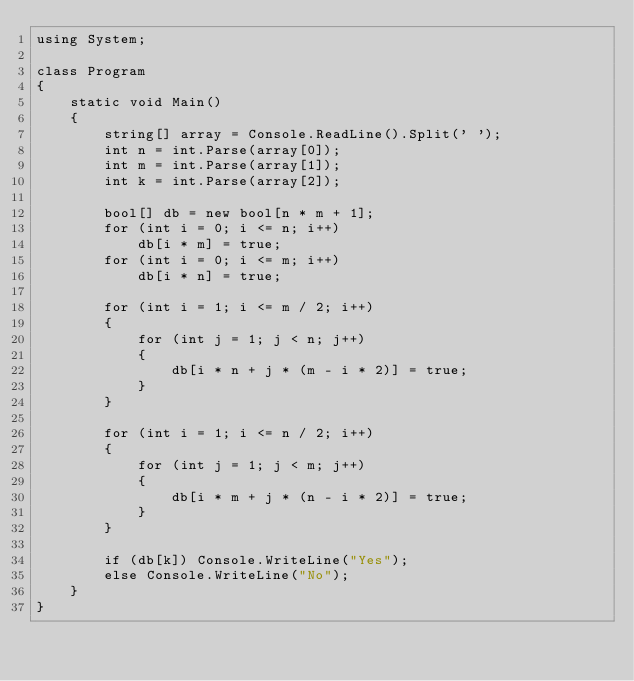<code> <loc_0><loc_0><loc_500><loc_500><_C#_>using System;

class Program
{
    static void Main()
    {
        string[] array = Console.ReadLine().Split(' ');
        int n = int.Parse(array[0]);
        int m = int.Parse(array[1]);
        int k = int.Parse(array[2]);

        bool[] db = new bool[n * m + 1];
        for (int i = 0; i <= n; i++)
            db[i * m] = true;
        for (int i = 0; i <= m; i++)
            db[i * n] = true;

        for (int i = 1; i <= m / 2; i++)
        {
            for (int j = 1; j < n; j++)
            {
                db[i * n + j * (m - i * 2)] = true;
            }
        }

        for (int i = 1; i <= n / 2; i++)
        {
            for (int j = 1; j < m; j++)
            {
                db[i * m + j * (n - i * 2)] = true;
            }
        }

        if (db[k]) Console.WriteLine("Yes");
        else Console.WriteLine("No");
    }
}</code> 